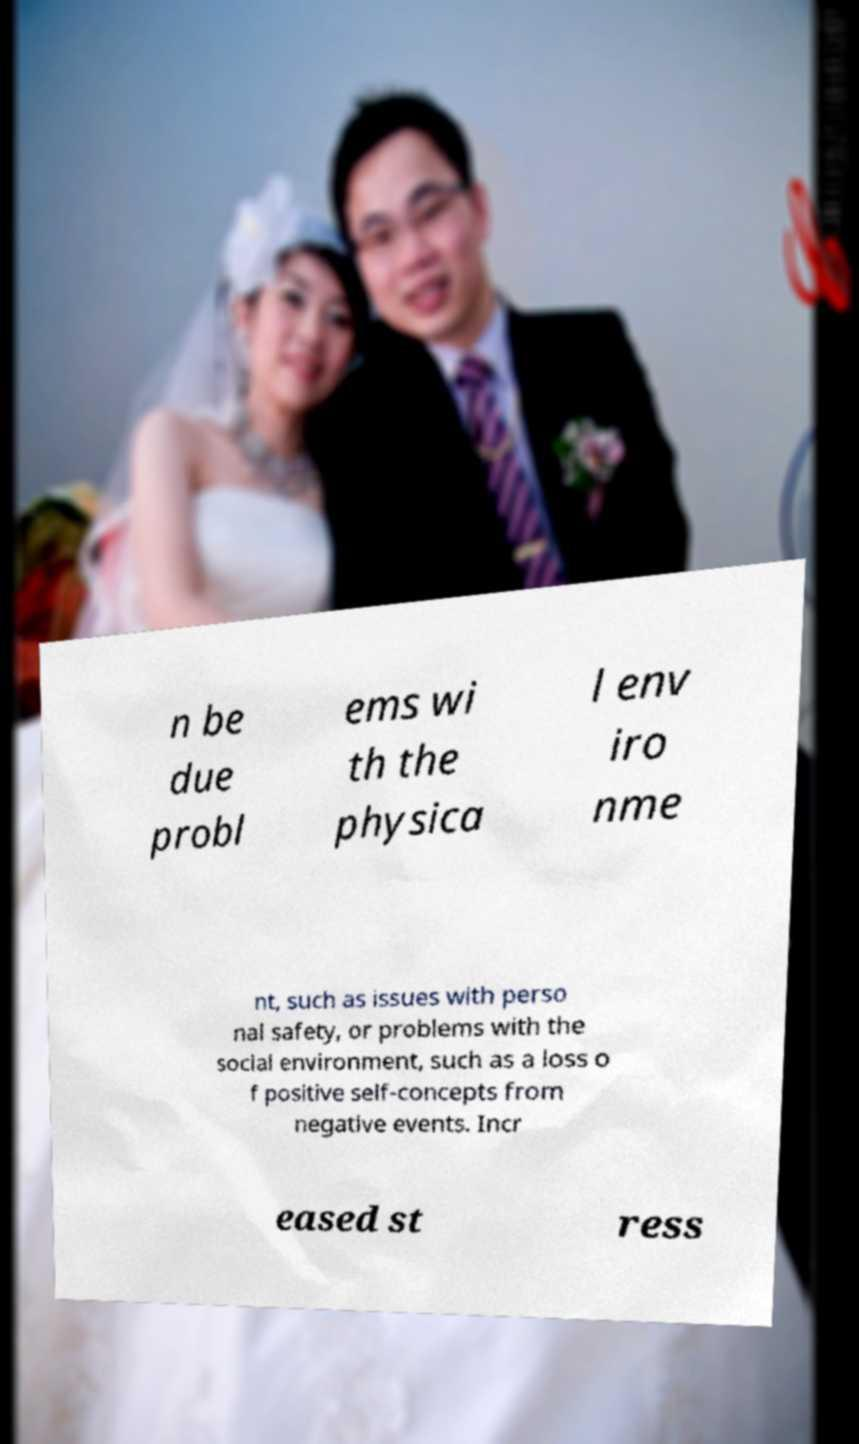Please identify and transcribe the text found in this image. n be due probl ems wi th the physica l env iro nme nt, such as issues with perso nal safety, or problems with the social environment, such as a loss o f positive self-concepts from negative events. Incr eased st ress 